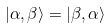<formula> <loc_0><loc_0><loc_500><loc_500>| \alpha , \beta \rangle = | \beta , \alpha \rangle</formula> 